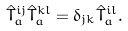Convert formula to latex. <formula><loc_0><loc_0><loc_500><loc_500>\hat { T } _ { a } ^ { i j } \hat { T } _ { a } ^ { k l } = \delta _ { j k } \hat { T } _ { a } ^ { i l } .</formula> 